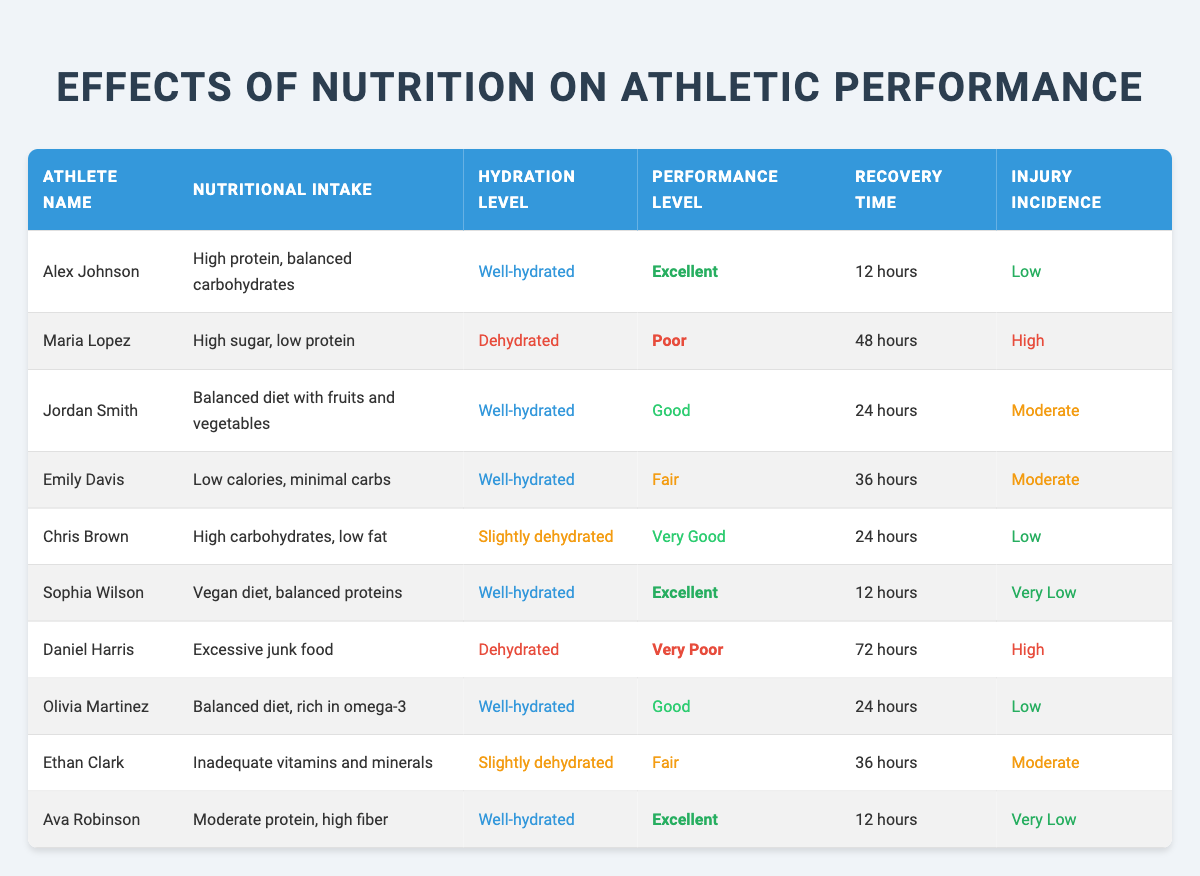What is the performance level of Alex Johnson? In the table, Alex Johnson's performance level is listed directly in the relevant row. It states "Excellent."
Answer: Excellent How many athletes have a hydration level classified as "Well-hydrated"? By counting the entries that state "Well-hydrated" in the hydration level column, we find 5 athletes: Alex Johnson, Jordan Smith, Sophia Wilson, Olivia Martinez, and Ava Robinson.
Answer: 5 Is there an athlete with the performance level categorized as "Very Poor"? In the table, Daniel Harris is marked with the performance level "Very Poor," confirming the existence of such an athlete.
Answer: Yes What is the recovery time for athletes with a "Low" injury incidence? The athletes with a "Low" injury incidence are Alex Johnson and Chris Brown. Their recovery times are 12 hours and 24 hours respectively. The average of these recovery times is (12 + 24) / 2 = 18 hours.
Answer: 18 hours Who has the best performance level among the athletes listed? Alex Johnson, Sophia Wilson, and Ava Robinson all have the performance level "Excellent," which is the highest. Therefore, multiple athletes share this performance level.
Answer: Alex Johnson, Sophia Wilson, Ava Robinson How does the nutritional intake of Maria Lopez correlate with her performance level? Maria Lopez has a "High sugar, low protein" nutritional intake, which correlates with a "Poor" performance level. Comparing her intake to others with better performance levels typically shows higher intake of proteins and balanced diets.
Answer: High sugar, low protein correlates with Poor performance What is the average recovery time for athletes who are "Dehydrated"? The athletes who are categorized as "Dehydrated" are Maria Lopez and Daniel Harris, with recovery times of 48 hours and 72 hours respectively. The average recovery time is calculated as (48 + 72) / 2 = 60 hours.
Answer: 60 hours Do any athletes exhibit both "Dehydrated" hydration levels and "High" injury incidence? Yes, both Maria Lopez and Daniel Harris are noted as "Dehydrated" and have high injury incidences listed. Hence, one can confirm that at least these two athletes exhibit both conditions.
Answer: Yes What is the difference in recovery time between the athlete with the highest performance level and the athlete with the lowest performance level? The highest performance level is "Excellent," with athletes having a recovery time of 12 hours (Alex Johnson, Sophia Wilson, Ava Robinson). The lowest performance level is "Very Poor," with Daniel Harris at 72 hours. The difference is 72 - 12 = 60 hours.
Answer: 60 hours 